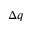<formula> <loc_0><loc_0><loc_500><loc_500>\Delta q</formula> 